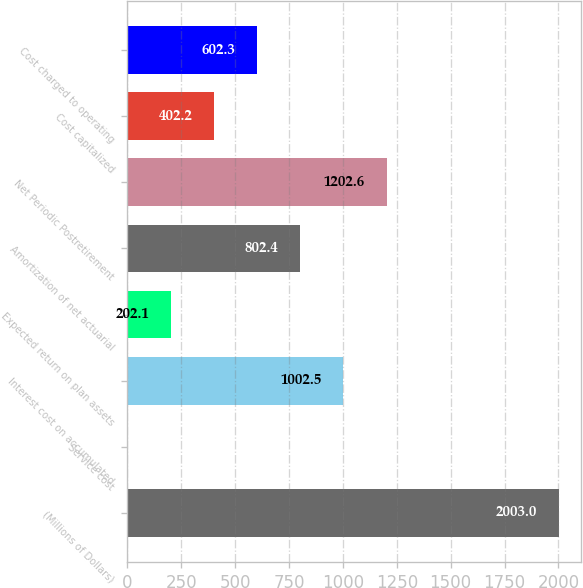Convert chart to OTSL. <chart><loc_0><loc_0><loc_500><loc_500><bar_chart><fcel>(Millions of Dollars)<fcel>Service cost<fcel>Interest cost on accumulated<fcel>Expected return on plan assets<fcel>Amortization of net actuarial<fcel>Net Periodic Postretirement<fcel>Cost capitalized<fcel>Cost charged to operating<nl><fcel>2003<fcel>2<fcel>1002.5<fcel>202.1<fcel>802.4<fcel>1202.6<fcel>402.2<fcel>602.3<nl></chart> 